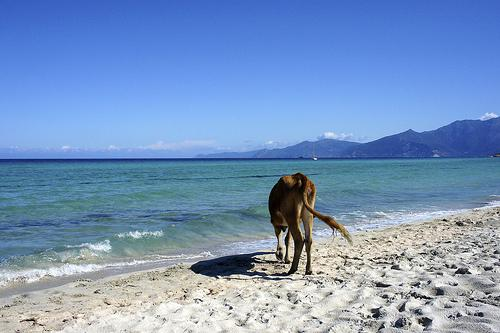Question: how many cows?
Choices:
A. 2.
B. 3.
C. 1.
D. 4.
Answer with the letter. Answer: C Question: when will the cow leave?
Choices:
A. Now.
B. Soon.
C. Later.
D. Never.
Answer with the letter. Answer: B Question: what is in the background?
Choices:
A. Ocean.
B. Desert.
C. Mountains.
D. Beach.
Answer with the letter. Answer: C Question: where is the cow?
Choices:
A. On the grass.
B. Next to the water.
C. By the fence.
D. In the barn.
Answer with the letter. Answer: B 